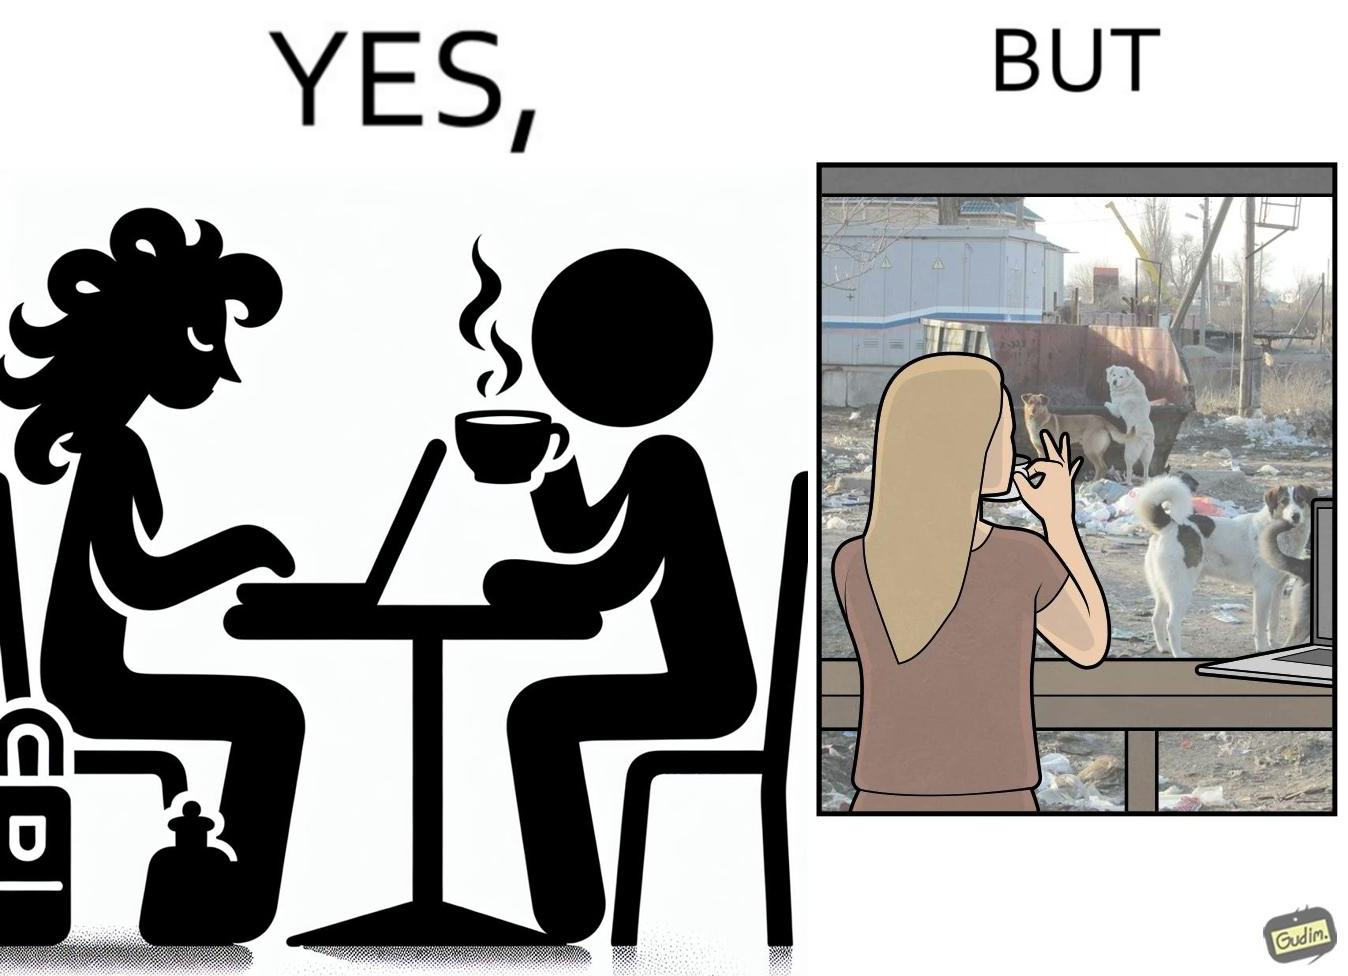Is there satirical content in this image? Yes, this image is satirical. 